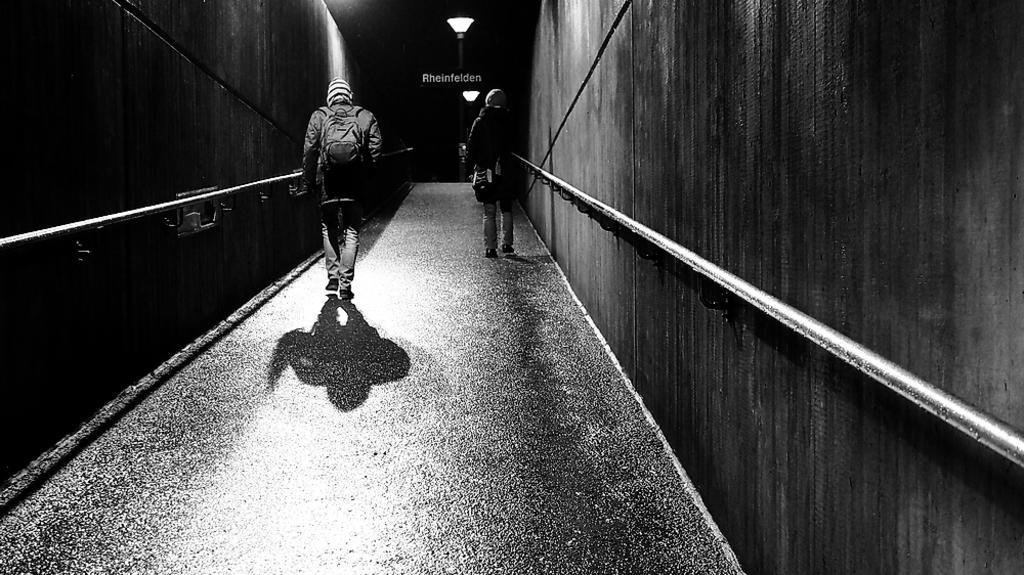Describe this image in one or two sentences. In this image, we can see people wearing bags and walking. In the background, there is a light and there is a wall. 